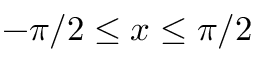<formula> <loc_0><loc_0><loc_500><loc_500>- \pi / 2 \leq x \leq \pi / 2</formula> 